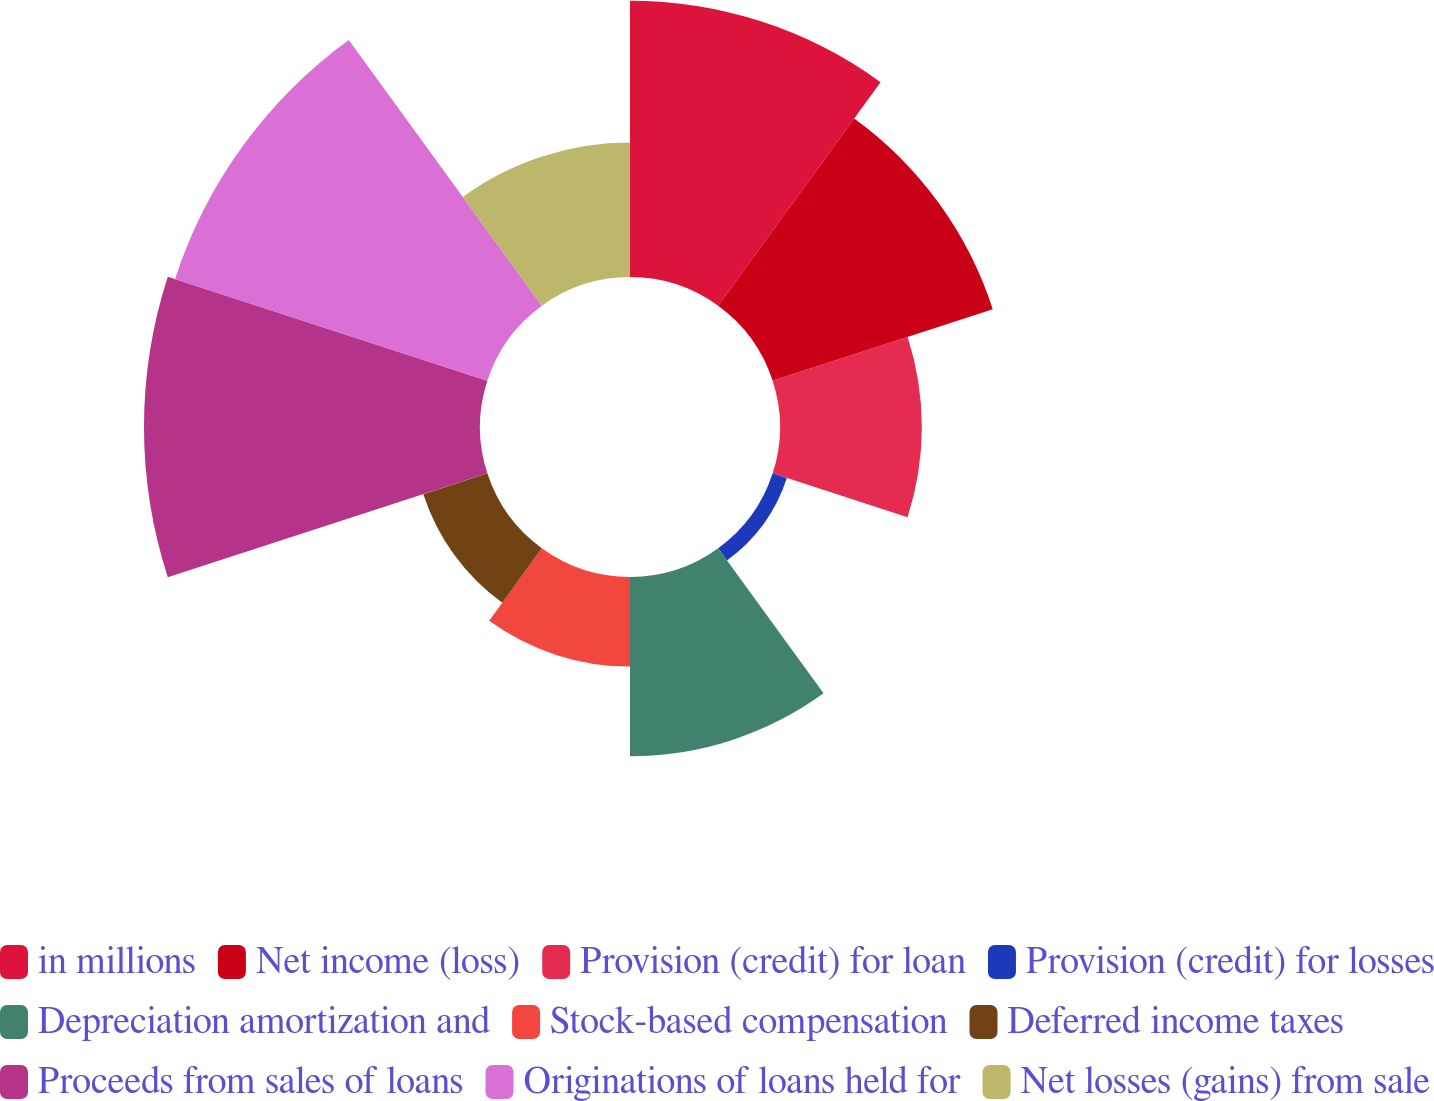<chart> <loc_0><loc_0><loc_500><loc_500><pie_chart><fcel>in millions<fcel>Net income (loss)<fcel>Provision (credit) for loan<fcel>Provision (credit) for losses<fcel>Depreciation amortization and<fcel>Stock-based compensation<fcel>Deferred income taxes<fcel>Proceeds from sales of loans<fcel>Originations of loans held for<fcel>Net losses (gains) from sale<nl><fcel>15.35%<fcel>12.86%<fcel>7.88%<fcel>0.83%<fcel>9.96%<fcel>4.98%<fcel>3.74%<fcel>18.67%<fcel>18.25%<fcel>7.47%<nl></chart> 